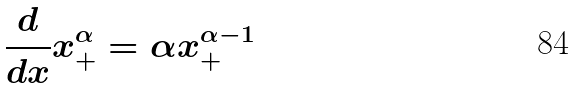<formula> <loc_0><loc_0><loc_500><loc_500>\frac { d } { d x } x _ { + } ^ { \alpha } = \alpha x _ { + } ^ { \alpha - 1 }</formula> 